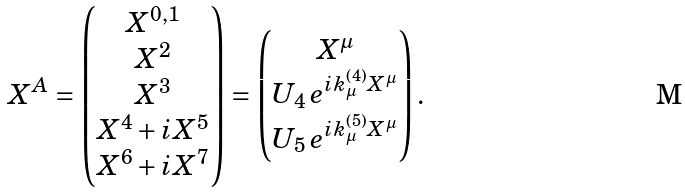<formula> <loc_0><loc_0><loc_500><loc_500>X ^ { A } = \begin{pmatrix} X ^ { 0 , 1 } \\ X ^ { 2 } \\ X ^ { 3 } \\ { X ^ { 4 } } + i { X ^ { 5 } } \\ { X ^ { 6 } } + i { X ^ { 7 } } \end{pmatrix} = \begin{pmatrix} X ^ { \mu } \\ U _ { 4 } \, e ^ { i k ^ { ( 4 ) } _ { \mu } X ^ { \mu } } \\ U _ { 5 } \, e ^ { i k ^ { ( 5 ) } _ { \mu } X ^ { \mu } } \end{pmatrix} .</formula> 